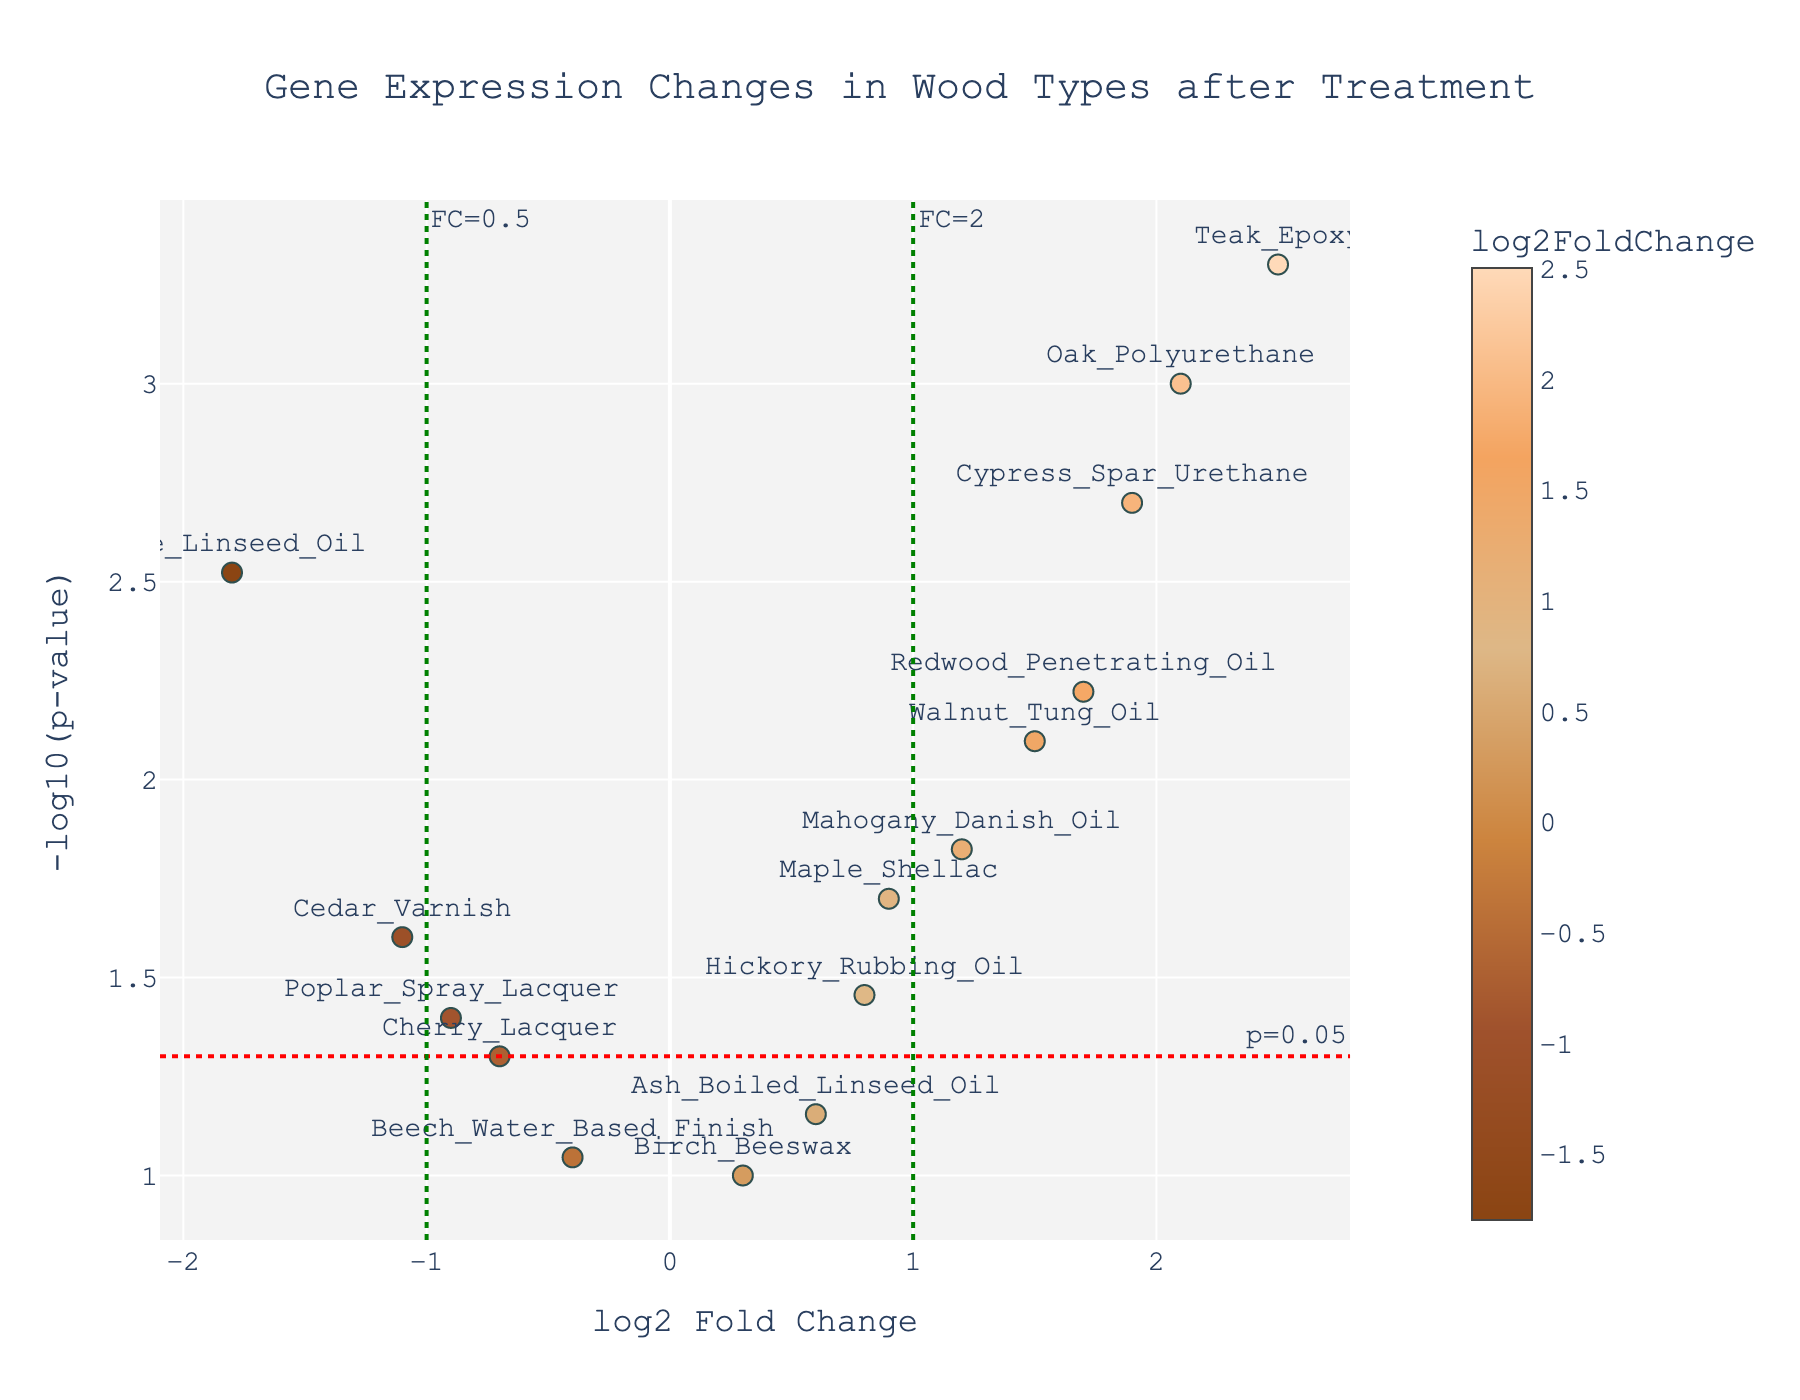Which gene has the highest log2 Fold Change? The highest log2 Fold Change can be identified by looking at the point furthest to the right on the x-axis.
Answer: Teak_Epoxy Which genes have a p-value less than 0.05? The genes with p-values less than 0.05 are those above the horizontal line at -log10(p-value) = 1.3 (since -log10(0.05) ≈ 1.3).
Answer: Oak_Polyurethane, Pine_Linseed_Oil, Maple_Shellac, Walnut_Tung_Oil, Mahogany_Danish_Oil, Cedar_Varnish, Redwood_Penetrating_Oil, Poplar_Spray_Lacquer, Hickory_Rubbing_Oil, Cypress_Spar_Urethane, Teak_Epoxy Among the genes with a p-value less than 0.05, which has the lowest log2 Fold Change? Among the genes above the horizontal dot line, the one with the furthest left position on the x-axis has the lowest log2 Fold Change.
Answer: Pine_Linseed_Oil What is the log2 Fold Change for Redwood_Penetrating_Oil? Locate the gene Redwood_Penetrating_Oil on the plot and read its x-axis value.
Answer: 1.7 How many genes have a log2 Fold Change greater than 1? Count the number of points to the right of the vertical green dot line at log2 Fold Change = 1.
Answer: 4 Which gene has the highest p-value? The gene with the highest p-value is the one with the lowest position on the y-axis.
Answer: Birch_Beeswax What is the log2 Fold Change and p-value for Oak_Polyurethane? Hover over the Oak_Polyurethane point or find its coordinates on the plot: x-axis is log2 Fold Change, y-axis is -log10(p-value).
Answer: 2.1, 0.001 Which genes have a log2 Fold Change between -1 and 1 and a p-value less than 0.05? Look for genes positioned between the vertical green dot lines and above the horizontal red dot line.
Answer: Maple_Shellac, Cedar_Varnish, Poplar_Spray_Lacquer, Hickory_Rubbing_Oil What is the range of the log2 Fold Change values? Determine the difference between the maximum and minimum values on the x-axis.
Answer: -1.8 to 2.5 